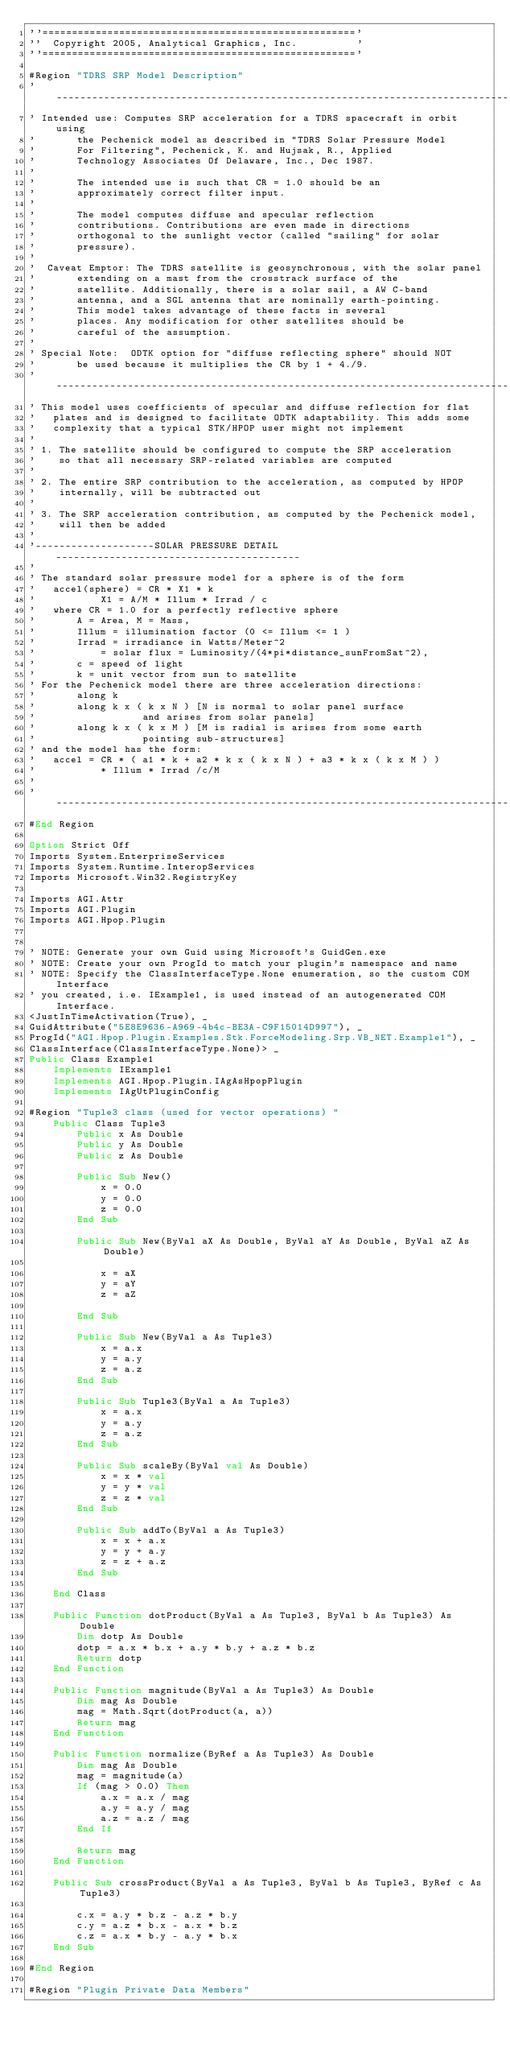<code> <loc_0><loc_0><loc_500><loc_500><_VisualBasic_>''====================================================='
''  Copyright 2005, Analytical Graphics, Inc.          '
''====================================================='

#Region "TDRS SRP Model Description"
'-----------------------------------------------------------------------------------
' Intended use:	Computes SRP acceleration for a TDRS spacecraft in orbit using
'				the Pechenick model as described in "TDRS Solar Pressure Model
'				For Filtering", Pechenick, K. and Hujsak, R., Applied
'				Technology Associates Of Delaware, Inc., Dec 1987.
'
'				The intended use is such that CR = 1.0 should be an
'				approximately correct filter input.
'
'				The model computes diffuse and specular reflection 
'				contributions. Contributions are even made in directions
'				orthogonal to the sunlight vector (called "sailing" for solar 
'				pressure).
'
'  Caveat Emptor: The TDRS satellite is geosynchronous, with the solar panel 
'				extending on a mast from the crosstrack surface of the 
'				satellite. Additionally, there is a solar sail, a AW C-band 
'				antenna, and a SGL antenna that are nominally earth-pointing.
'				This model takes advantage of these facts in several
'				places. Any modification for other satellites should be 
'				careful of the assumption.
'
'	Special Note:  ODTK option for "diffuse reflecting sphere" should NOT 
'				be used because it multiplies the CR by 1 + 4./9.
'-----------------------------------------------------------------------------------
'	This model uses coefficients of specular and diffuse reflection for flat 
'		plates and is designed to facilitate ODTK adaptability. This adds some
'		complexity that a typical STK/HPOP user might not implement
'
'	1. The satellite should be configured to compute the SRP acceleration 
'	   so that all necessary SRP-related variables are computed
'
'	2. The entire SRP contribution to the acceleration, as computed by HPOP 
'	   internally, will be subtracted out
'
'	3. The SRP acceleration contribution, as computed by the Pechenick model,
'	   will then be added
'
'--------------------SOLAR PRESSURE DETAIL-----------------------------------------
'
'	The standard solar pressure model for a sphere is of the form
'		accel(sphere) = CR * X1 * k
'           X1 = A/M * Illum * Irrad / c
'		where CR = 1.0 for a perfectly reflective sphere
'				A = Area, M = Mass, 
'				Illum = illumination factor (0 <= Illum <= 1 )
'				Irrad = irradiance in Watts/Meter^2 
'					  = solar flux = Luminosity/(4*pi*distance_sunFromSat^2),
'				c = speed of light
'				k = unit vector from sun to satellite
'	For the Pechenick model there are three acceleration directions: 
'				along k
'				along k x ( k x N ) [N is normal to solar panel surface
'									 and arises from solar panels]
'				along k x ( k x M ) [M is radial is arises from some earth
'									 pointing sub-structures]
'	and the model has the form:
'		accel = CR * ( a1 * k + a2 * k x ( k x N ) + a3 * k x ( k x M ) ) 
'						* Illum * Irrad /c/M
'
'-----------------------------------------------------------------------------------
#End Region

Option Strict Off
Imports System.EnterpriseServices
Imports System.Runtime.InteropServices
Imports Microsoft.Win32.RegistryKey

Imports AGI.Attr
Imports AGI.Plugin
Imports AGI.Hpop.Plugin


' NOTE: Generate your own Guid using Microsoft's GuidGen.exe
' NOTE: Create your own ProgId to match your plugin's namespace and name
' NOTE: Specify the ClassInterfaceType.None enumeration, so the custom COM Interface 
' you created, i.e. IExample1, is used instead of an autogenerated COM Interface.
<JustInTimeActivation(True), _
GuidAttribute("5E8E9636-A969-4b4c-BE3A-C9F15014D997"), _
ProgId("AGI.Hpop.Plugin.Examples.Stk.ForceModeling.Srp.VB_NET.Example1"), _
ClassInterface(ClassInterfaceType.None)> _
Public Class Example1
    Implements IExample1
    Implements AGI.Hpop.Plugin.IAgAsHpopPlugin
    Implements IAgUtPluginConfig

#Region "Tuple3 class (used for vector operations) "
    Public Class Tuple3
        Public x As Double
        Public y As Double
        Public z As Double

        Public Sub New()
            x = 0.0
            y = 0.0
            z = 0.0
        End Sub

        Public Sub New(ByVal aX As Double, ByVal aY As Double, ByVal aZ As Double)

            x = aX
            y = aY
            z = aZ

        End Sub

        Public Sub New(ByVal a As Tuple3)
            x = a.x
            y = a.y
            z = a.z
        End Sub

        Public Sub Tuple3(ByVal a As Tuple3)
            x = a.x
            y = a.y
            z = a.z
        End Sub

        Public Sub scaleBy(ByVal val As Double)
            x = x * val
            y = y * val
            z = z * val
        End Sub

        Public Sub addTo(ByVal a As Tuple3)
            x = x + a.x
            y = y + a.y
            z = z + a.z
        End Sub

    End Class

    Public Function dotProduct(ByVal a As Tuple3, ByVal b As Tuple3) As Double
        Dim dotp As Double
        dotp = a.x * b.x + a.y * b.y + a.z * b.z
        Return dotp
    End Function

    Public Function magnitude(ByVal a As Tuple3) As Double
        Dim mag As Double
        mag = Math.Sqrt(dotProduct(a, a))
        Return mag
    End Function

    Public Function normalize(ByRef a As Tuple3) As Double
        Dim mag As Double
        mag = magnitude(a)
        If (mag > 0.0) Then
            a.x = a.x / mag
            a.y = a.y / mag
            a.z = a.z / mag
        End If

        Return mag
    End Function

    Public Sub crossProduct(ByVal a As Tuple3, ByVal b As Tuple3, ByRef c As Tuple3)

        c.x = a.y * b.z - a.z * b.y
        c.y = a.z * b.x - a.x * b.z
        c.z = a.x * b.y - a.y * b.x
    End Sub

#End Region

#Region "Plugin Private Data Members"
</code> 